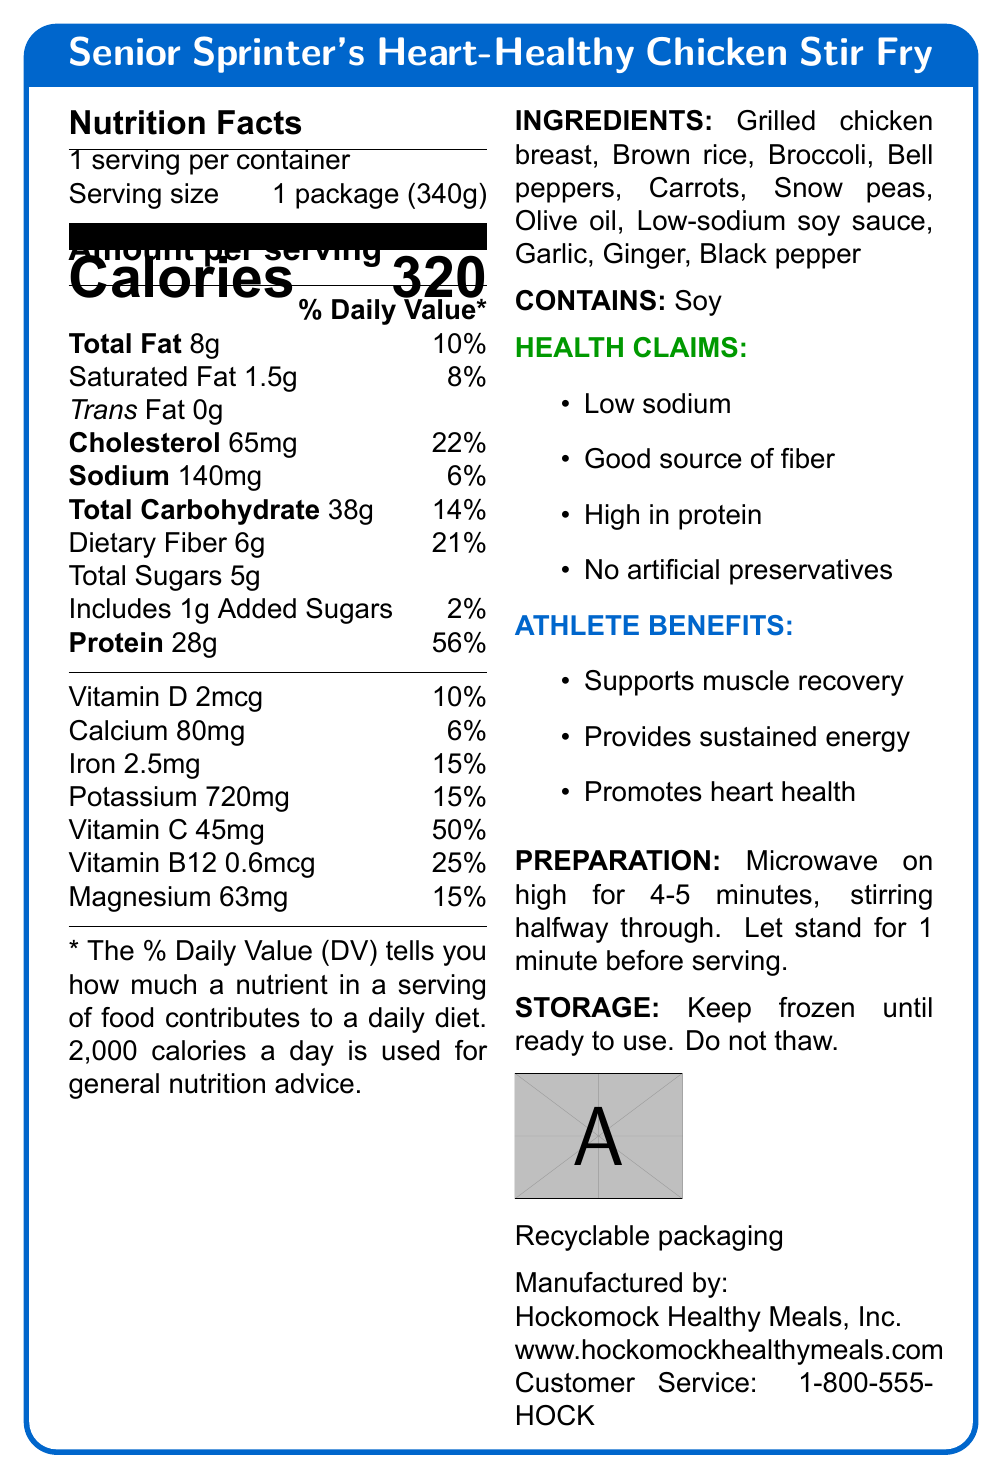how many servings are in one container? The document states "1 serving per container."
Answer: 1 what is the serving size? The serving size is specified as "1 package (340g)."
Answer: 1 package (340g) how many calories are in one serving? The document lists the calories per serving as 320.
Answer: 320 what is the percentage daily value for total fat? The percentage daily value for total fat is given as 10%.
Answer: 10% what are the preparation instructions? The document provides these specific preparation instructions.
Answer: Microwave on high for 4-5 minutes, stirring halfway through. Let stand for 1 minute before serving. which nutrient has the highest % daily value? A. Cholesterol B. Protein C. Sodium D. Vitamin C The % daily value for Protein is 56%, which is the highest among the listed nutrients.
Answer: B. Protein what ingredients are included in the meal? A. Olive oil B. Chicken broth C. Brown rice D. Snow peas The ingredients listed include Olive oil, Brown rice, and Snow peas.
Answer: A, C, D is this product high in protein? The health claims section specifically states "High in protein."
Answer: Yes what company manufactures this product? The manufacturer is listed as “Hockomock Healthy Meals, Inc.”
Answer: Hockomock Healthy Meals, Inc. is the packaging recyclable? The document states "Recyclable packaging."
Answer: Yes what are the health benefits of this meal? The "athlete benefits" section lists these health benefits.
Answer: Supports muscle recovery, provides sustained energy, promotes heart health does this product contain any allergens? The document lists Soy as an allergen.
Answer: Yes, Soy provide a summary of the entire document This summary covers the key elements and information specified in the document.
Answer: The document provides the Nutrition Facts Label for the "Senior Sprinter's Heart-Healthy Chicken Stir Fry." It contains details about serving size, calories, nutrient percentages, ingredients, allergens, health claims, athletic benefits, and preparation and storage instructions. The product is manufactured by Hockomock Healthy Meals, Inc., and comes in recyclable packaging. what is the customer service phone number? The customer service phone number is listed as "1-800-555-HOCK."
Answer: 1-800-555-HOCK is the product low in sodium? The health claims section specifically mentions "Low sodium."
Answer: Yes what are the storage instructions? The document provides these specific storage instructions.
Answer: Keep frozen until ready to use. Do not thaw. what are the specific amounts of vitamin D and calcium in the meal? The nutrition facts section lists Vitamin D as 2 mcg and Calcium as 80 mg.
Answer: Vitamin D: 2 mcg, Calcium: 80 mg calculate the amount of fiber per gram of the meal? With 6g of dietary fiber in a 340g serving, the calculation is 6g/340g = 0.0176 g/g.
Answer: 0.0176 g/g (approx) what are the benefits of the nutrients with the highest % daily value? Protein has the highest % daily value at 56%, indicating it is significant for muscle recovery and body function.
Answer: Protein supports muscle recovery and overall body function. will this meal help in muscle recovery? The athlete benefits section specifically mentions "supports muscle recovery."
Answer: Yes what is the main idea of this document? The main idea is to convey nutritional details and benefits for the "Senior Sprinter's Heart-Healthy Chicken Stir Fry."
Answer: This document provides detailed nutritional information, ingredients, health claims, and additional instructions for a low-sodium, heart-healthy frozen meal designed for active retirees. is the low-sodium soy sauce used organic? The document does not mention whether the low-sodium soy sauce is organic.
Answer: Not enough information 